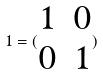Convert formula to latex. <formula><loc_0><loc_0><loc_500><loc_500>1 = ( \begin{matrix} 1 & 0 \\ 0 & 1 \end{matrix} )</formula> 